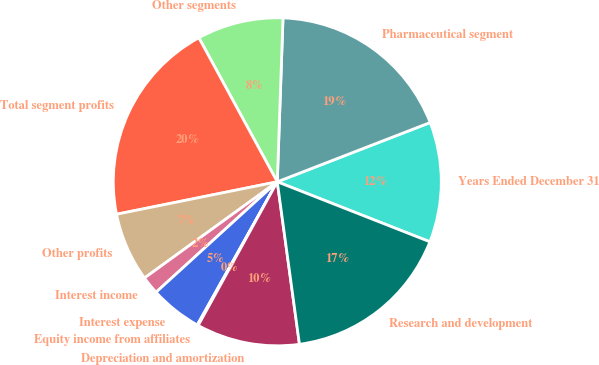<chart> <loc_0><loc_0><loc_500><loc_500><pie_chart><fcel>Years Ended December 31<fcel>Pharmaceutical segment<fcel>Other segments<fcel>Total segment profits<fcel>Other profits<fcel>Interest income<fcel>Interest expense<fcel>Equity income from affiliates<fcel>Depreciation and amortization<fcel>Research and development<nl><fcel>11.85%<fcel>18.56%<fcel>8.49%<fcel>20.24%<fcel>6.81%<fcel>1.78%<fcel>5.13%<fcel>0.1%<fcel>10.17%<fcel>16.88%<nl></chart> 